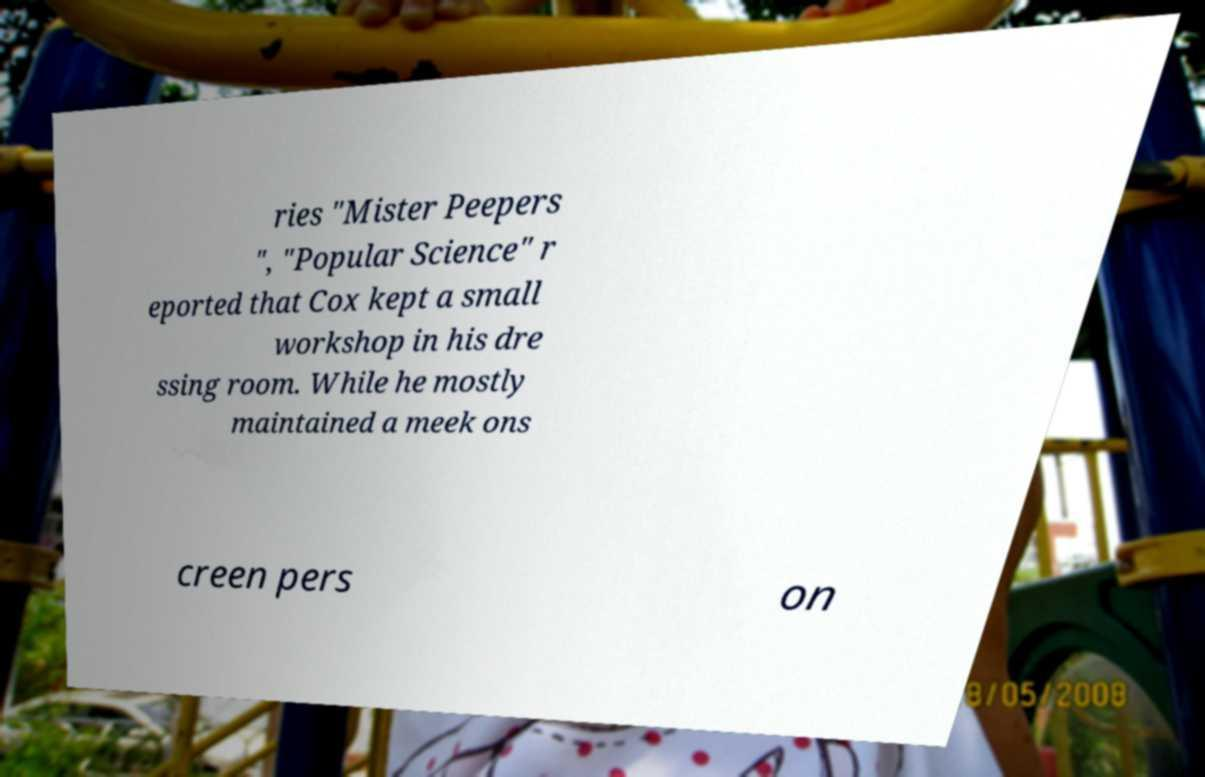Can you read and provide the text displayed in the image?This photo seems to have some interesting text. Can you extract and type it out for me? ries "Mister Peepers ", "Popular Science" r eported that Cox kept a small workshop in his dre ssing room. While he mostly maintained a meek ons creen pers on 